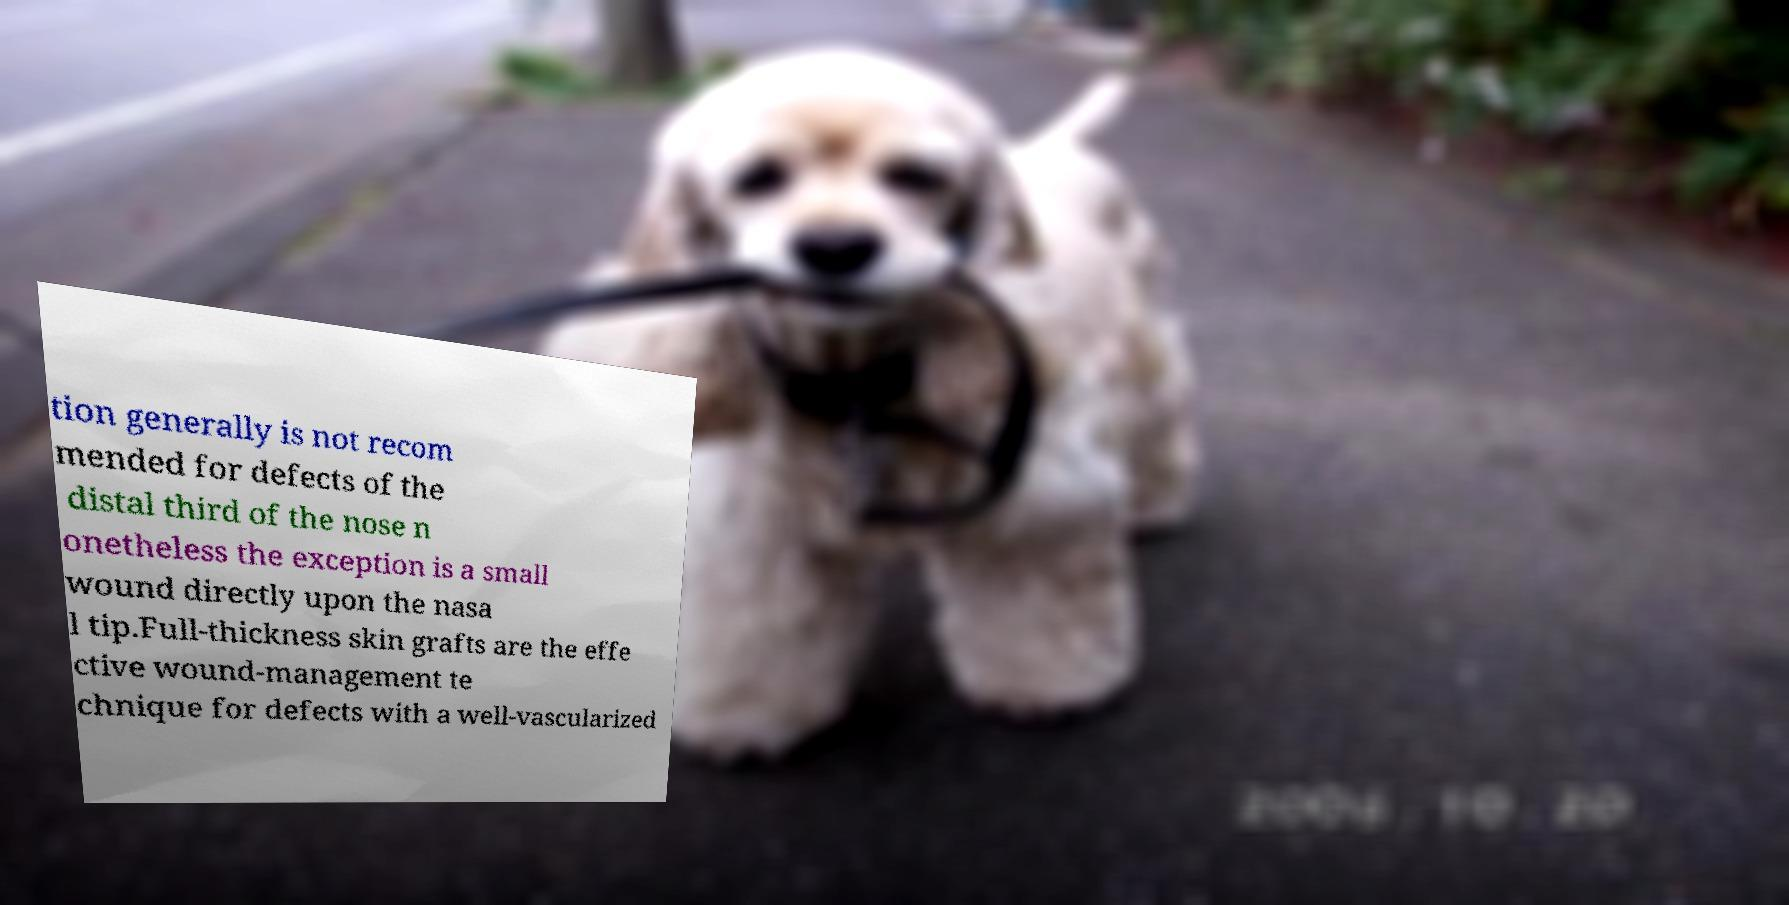Can you read and provide the text displayed in the image?This photo seems to have some interesting text. Can you extract and type it out for me? tion generally is not recom mended for defects of the distal third of the nose n onetheless the exception is a small wound directly upon the nasa l tip.Full-thickness skin grafts are the effe ctive wound-management te chnique for defects with a well-vascularized 